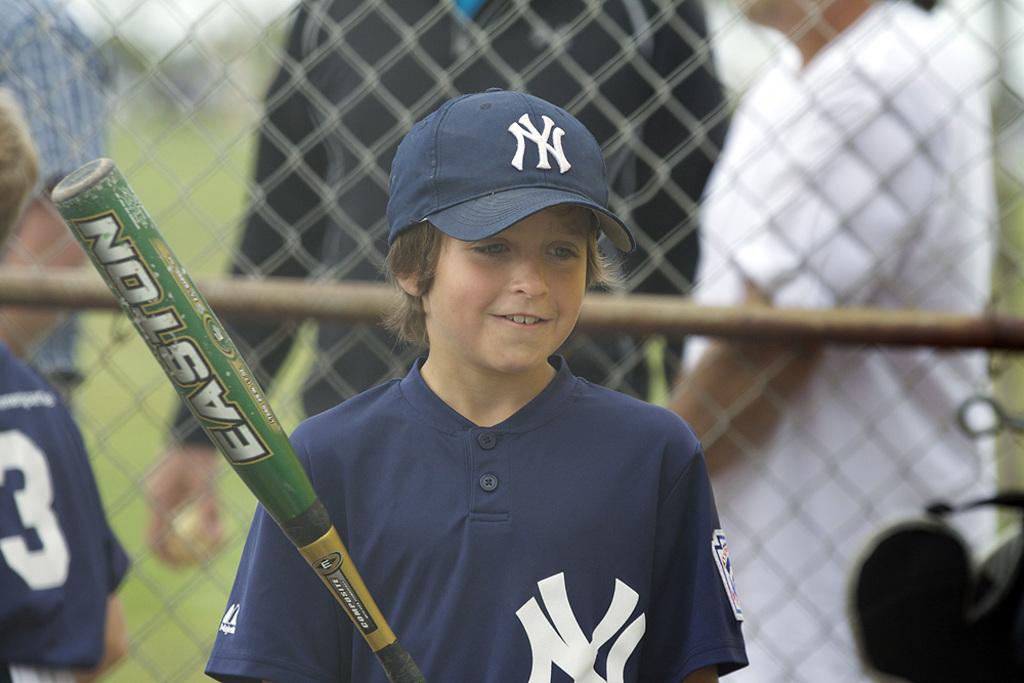Is the bat an easton?
Provide a short and direct response. Yes. 